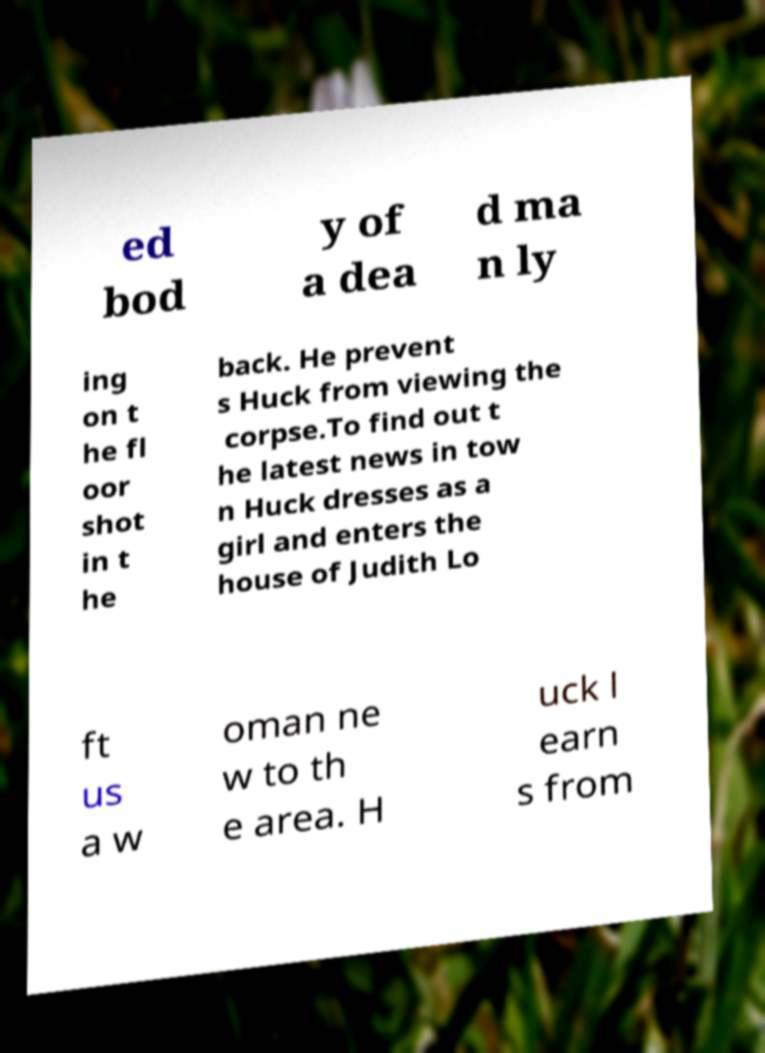Could you extract and type out the text from this image? ed bod y of a dea d ma n ly ing on t he fl oor shot in t he back. He prevent s Huck from viewing the corpse.To find out t he latest news in tow n Huck dresses as a girl and enters the house of Judith Lo ft us a w oman ne w to th e area. H uck l earn s from 